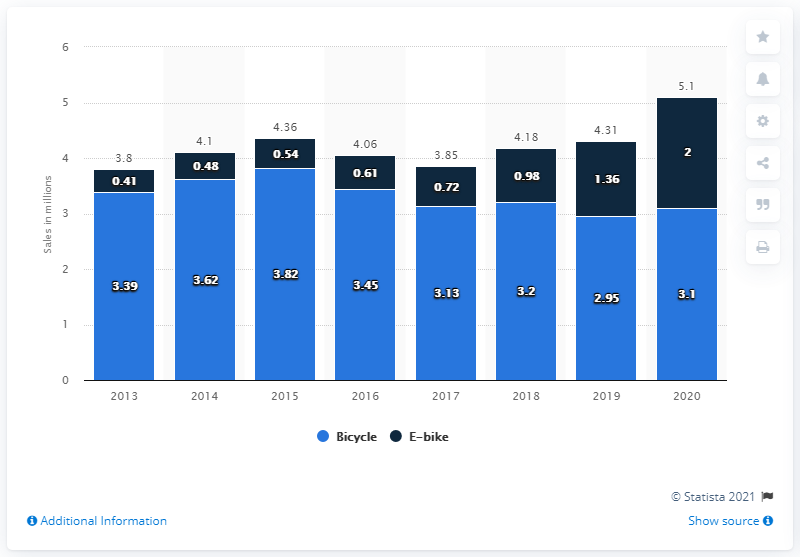Indicate a few pertinent items in this graphic. In 2020, it is estimated that approximately 2 million electric bicycles were sold in Germany. 